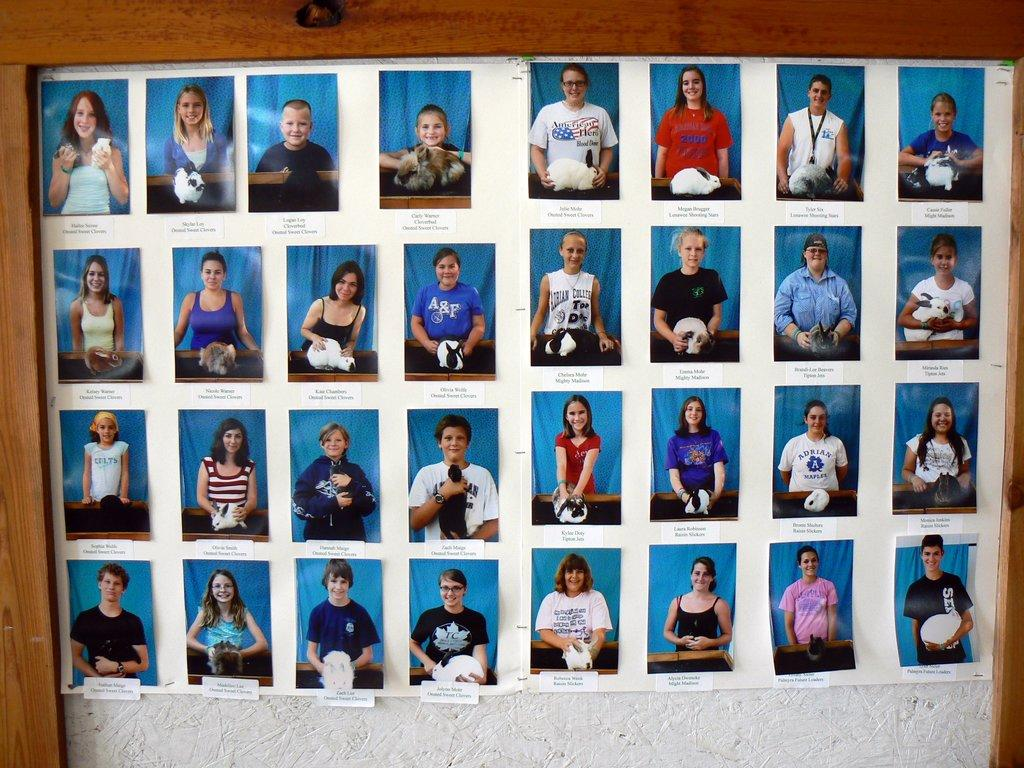What type of images are included in the collage in the image? The collage photographs include images of men and women. Where are the photographs located in the image? The photographs are placed on a white board. What can be inferred about the purpose of the collage based on the images? The collage may be a representation of people or a group, given the presence of images of men and women. What type of trouble does the robin cause in the image? There is no robin present in the image, so it cannot cause any trouble. 